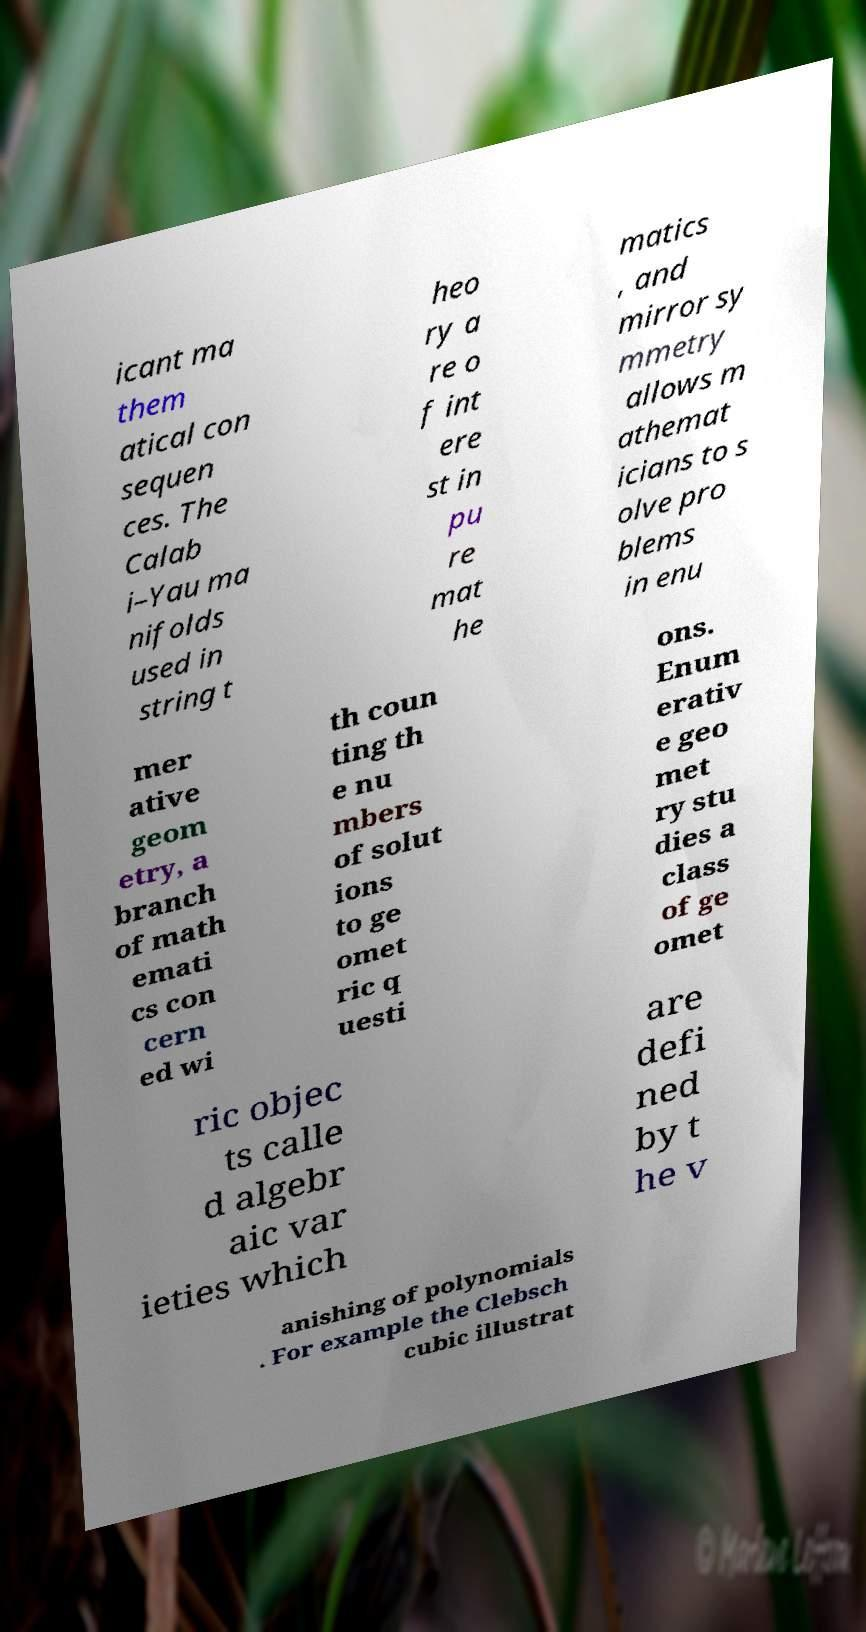There's text embedded in this image that I need extracted. Can you transcribe it verbatim? icant ma them atical con sequen ces. The Calab i–Yau ma nifolds used in string t heo ry a re o f int ere st in pu re mat he matics , and mirror sy mmetry allows m athemat icians to s olve pro blems in enu mer ative geom etry, a branch of math emati cs con cern ed wi th coun ting th e nu mbers of solut ions to ge omet ric q uesti ons. Enum erativ e geo met ry stu dies a class of ge omet ric objec ts calle d algebr aic var ieties which are defi ned by t he v anishing of polynomials . For example the Clebsch cubic illustrat 